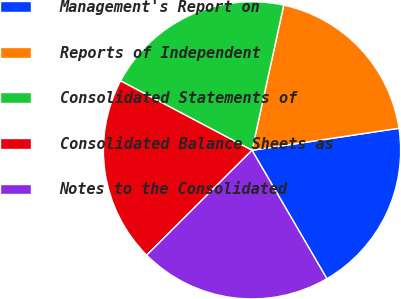Convert chart. <chart><loc_0><loc_0><loc_500><loc_500><pie_chart><fcel>Management's Report on<fcel>Reports of Independent<fcel>Consolidated Statements of<fcel>Consolidated Balance Sheets as<fcel>Notes to the Consolidated<nl><fcel>18.97%<fcel>19.21%<fcel>20.69%<fcel>20.2%<fcel>20.94%<nl></chart> 